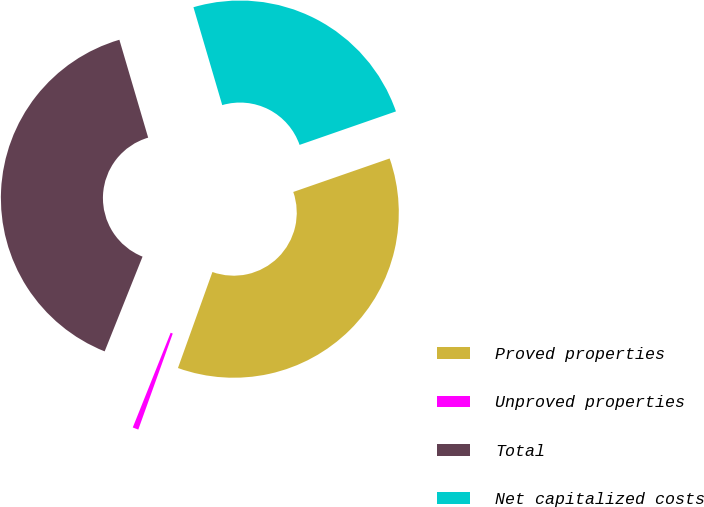Convert chart. <chart><loc_0><loc_0><loc_500><loc_500><pie_chart><fcel>Proved properties<fcel>Unproved properties<fcel>Total<fcel>Net capitalized costs<nl><fcel>35.81%<fcel>0.57%<fcel>39.39%<fcel>24.23%<nl></chart> 